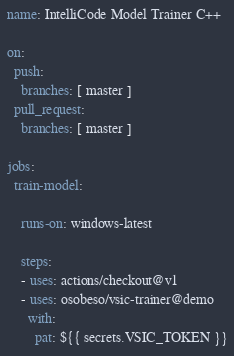Convert code to text. <code><loc_0><loc_0><loc_500><loc_500><_YAML_>name: IntelliCode Model Trainer C++

on:
  push:
    branches: [ master ]
  pull_request:
    branches: [ master ]

jobs:
  train-model:
    
    runs-on: windows-latest

    steps:
    - uses: actions/checkout@v1
    - uses: osobeso/vsic-trainer@demo
      with:
        pat: ${{ secrets.VSIC_TOKEN }}
</code> 